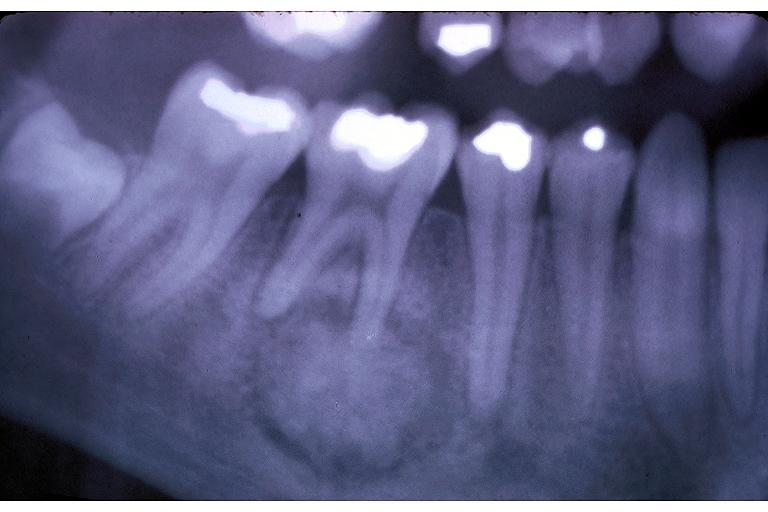what does this image show?
Answer the question using a single word or phrase. Cementoblastoma 